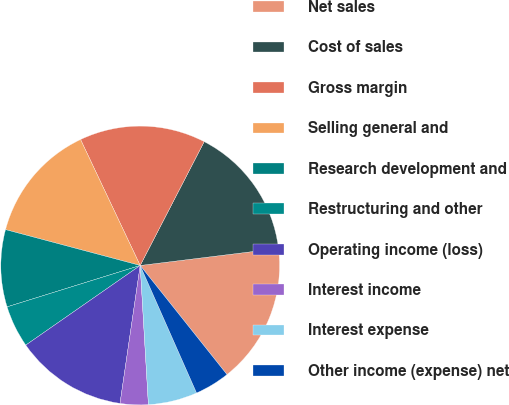Convert chart. <chart><loc_0><loc_0><loc_500><loc_500><pie_chart><fcel>Net sales<fcel>Cost of sales<fcel>Gross margin<fcel>Selling general and<fcel>Research development and<fcel>Restructuring and other<fcel>Operating income (loss)<fcel>Interest income<fcel>Interest expense<fcel>Other income (expense) net<nl><fcel>16.26%<fcel>15.45%<fcel>14.63%<fcel>13.82%<fcel>8.94%<fcel>4.88%<fcel>13.01%<fcel>3.25%<fcel>5.69%<fcel>4.07%<nl></chart> 